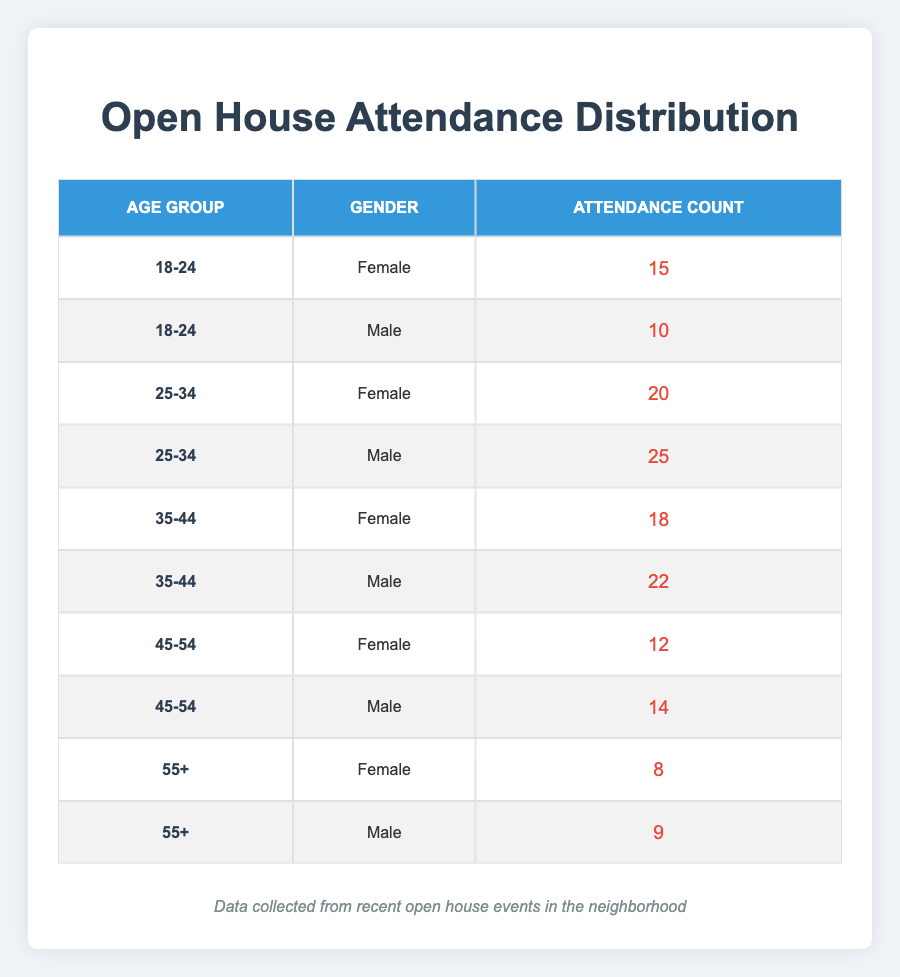What is the total attendance count for the age group 25-34? The attendance counts for the age group 25-34 are 20 (Female) and 25 (Male). Adding them gives 20 + 25 = 45.
Answer: 45 Which gender had a higher attendance in the 35-44 age group? In the 35-44 age group, there were 18 (Female) and 22 (Male). Since 22 is greater than 18, Male had a higher attendance.
Answer: Male What is the average attendance count for the age group 45-54? The attendance counts for the age group 45-54 are 12 (Female) and 14 (Male). The average is (12 + 14) / 2 = 26 / 2 = 13.
Answer: 13 Is it true that more females attended than males in the 55+ age group? In the 55+ age group, there are 8 (Female) and 9 (Male). Since 8 is less than 9, it is not true that more females attended.
Answer: No What percentage of the total attendance did the 18-24 age group represent? First, we sum the attendance counts: 15 (18-24 Female) + 10 (18-24 Male) + 20 (25-34 Female) + 25 (25-34 Male) + 18 (35-44 Female) + 22 (35-44 Male) + 12 (45-54 Female) + 14 (45-54 Male) + 8 (55+ Female) + 9 (55+ Male) =  15 + 10 + 20 + 25 + 18 + 22 + 12 + 14 + 8 + 9 =  153. The attendance for the 18-24 age group is 15 + 10 = 25. The percentage is (25 / 153) * 100 ≈ 16.34%.
Answer: Approximately 16.34% Which age group had the lowest overall attendance? By summing the attendance for each age group: 18-24 = 25, 25-34 = 45, 35-44 = 40, 45-54 = 26, and 55+ = 17. The lowest overall attendance is from the 55+ age group, with an attendance of 17.
Answer: 55+ What is the total number of male attendees across all age groups? To find the total number of male attendees, we add the counts: 10 (18-24) + 25 (25-34) + 22 (35-44) + 14 (45-54) + 9 (55+) = 10 + 25 + 22 + 14 + 9 = 80.
Answer: 80 